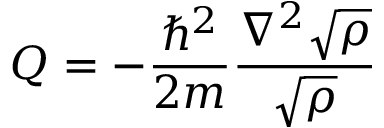<formula> <loc_0><loc_0><loc_500><loc_500>Q = - \frac { \hbar { ^ } { 2 } } { 2 m } \frac { \nabla ^ { 2 } \sqrt { \rho } } { \sqrt { \rho } }</formula> 